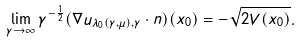<formula> <loc_0><loc_0><loc_500><loc_500>\lim _ { \gamma \rightarrow \infty } \gamma ^ { - \frac { 1 } 2 } ( \nabla u _ { \lambda _ { 0 } ( \gamma , \mu ) , \gamma } \cdot n ) ( x _ { 0 } ) = - \sqrt { 2 V ( x _ { 0 } ) } .</formula> 